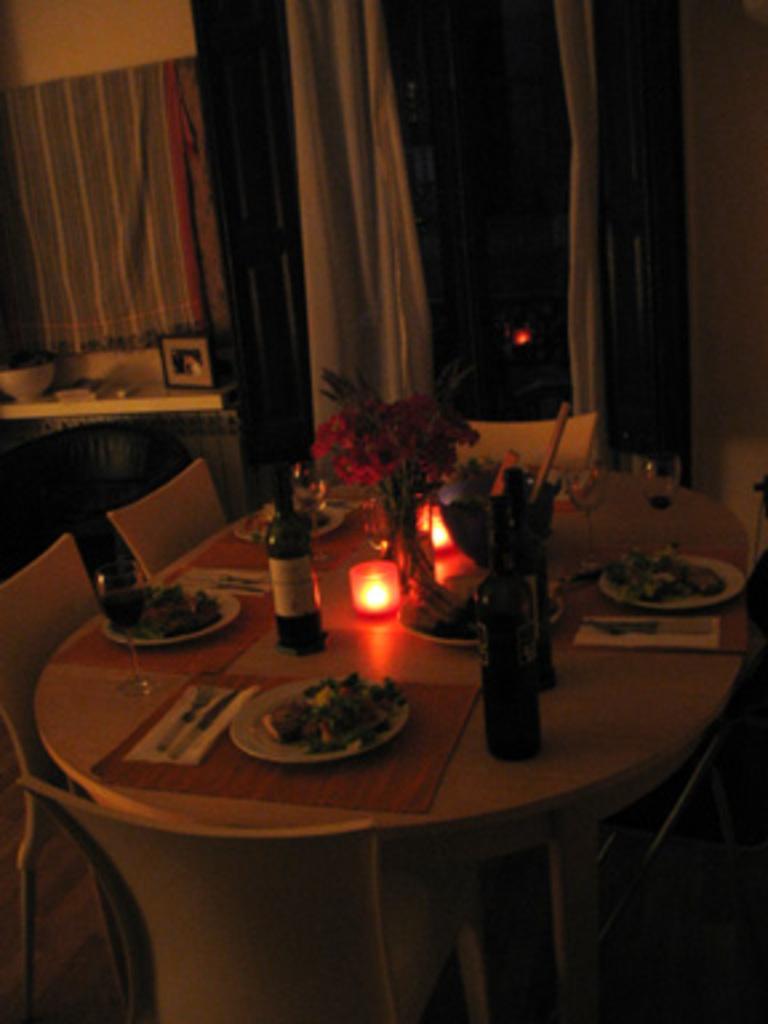Can you describe this image briefly? In the center of the image there is a dining table on which there is a candle. There is a flower vase. There are plates with food items. There are glasses. There are wine bottles. There are chairs. In the background of the image there is wall. There are curtains. 